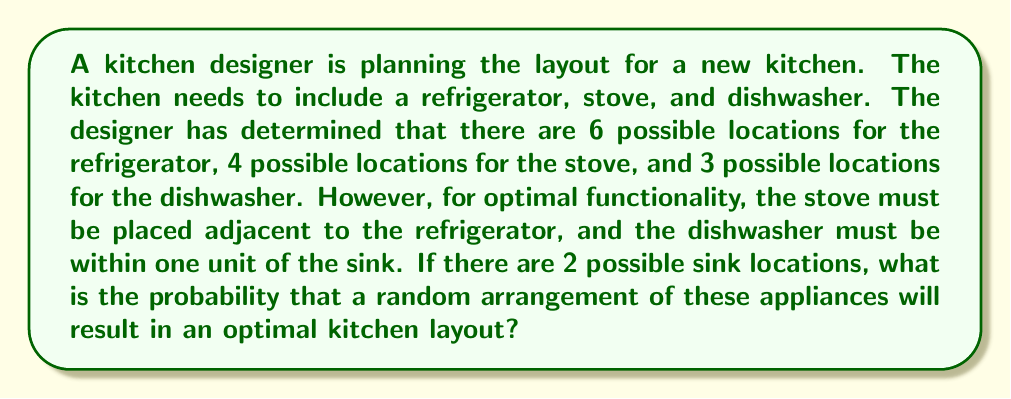Can you answer this question? Let's break this problem down step-by-step:

1) First, we need to calculate the total number of possible arrangements:
   Total arrangements = 6 (refrigerator) × 4 (stove) × 3 (dishwasher) = 72

2) Now, let's consider the optimal arrangements:
   a) The stove must be adjacent to the refrigerator. For each refrigerator position, there are typically 2 adjacent positions (assuming a linear layout). So we have:
      6 (refrigerator) × 2 (adjacent stove positions) = 12 possible refrigerator-stove combinations

   b) The dishwasher must be within one unit of the sink. With 2 possible sink locations, each sink location typically has 3 positions within one unit (including its own position). So we have:
      2 (sink locations) × 3 (dishwasher positions per sink) = 6 possible sink-dishwasher combinations

3) The number of optimal arrangements is thus:
   12 (refrigerator-stove combinations) × 6 (sink-dishwasher combinations) = 72

4) The probability is calculated by dividing the number of favorable outcomes by the total number of possible outcomes:

   $$P(\text{optimal arrangement}) = \frac{\text{number of optimal arrangements}}{\text{total number of arrangements}} = \frac{72}{72} = 1$$

This result might seem counterintuitive, but it's correct based on the given constraints. In a real kitchen design scenario, there would likely be additional constraints that would reduce this probability.
Answer: The probability of a random arrangement resulting in an optimal kitchen layout is 1 or 100%. 